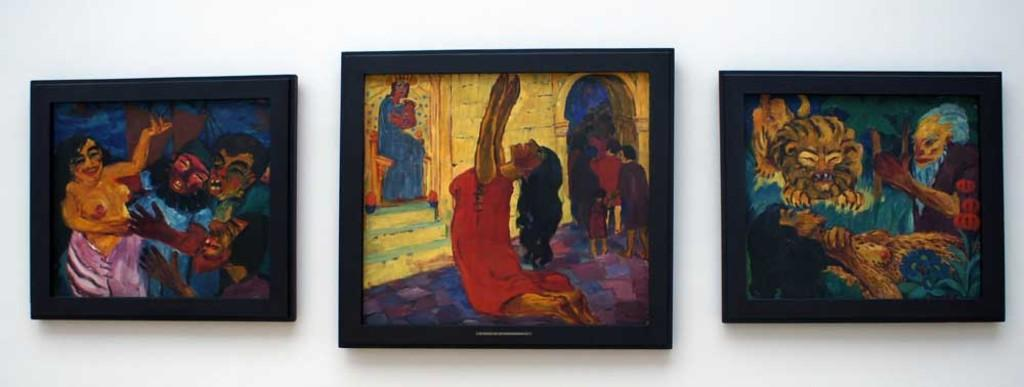What can be seen on the wall in the image? There are photo frames on a wall in the image. What is inside the photo frames? The photo frames contain paintings. How many rings are visible on the stage in the image? There is no stage or rings present in the image; it only features photo frames with paintings on a wall. 